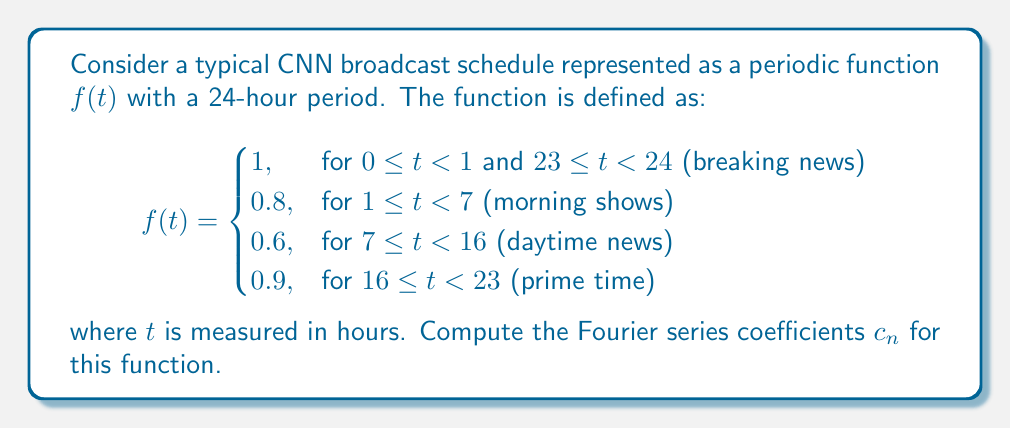Can you answer this question? To find the Fourier series coefficients, we need to use the formula:

$$c_n = \frac{1}{T} \int_0^T f(t) e^{-i2\pi nt/T} dt$$

where $T = 24$ hours is the period of our function.

Let's break down the integral into four parts corresponding to the different segments of the broadcast schedule:

1) $\int_0^1 1 \cdot e^{-i2\pi nt/24} dt$
2) $\int_1^7 0.8 \cdot e^{-i2\pi nt/24} dt$
3) $\int_7^{16} 0.6 \cdot e^{-i2\pi nt/24} dt$
4) $\int_{16}^{23} 0.9 \cdot e^{-i2\pi nt/24} dt$
5) $\int_{23}^{24} 1 \cdot e^{-i2\pi nt/24} dt$

For each integral, we use the formula $\int e^{ax} dx = \frac{1}{a}e^{ax} + C$. After evaluating the integrals and simplifying, we get:

$$c_n = \frac{1}{24} \left[ \frac{24}{2\pi in} \left( 1 \cdot (e^{-i\pi n/12} - 1) + 0.8 \cdot (e^{-i7\pi n/12} - e^{-i\pi n/12}) \right. \right.$$
$$\left. \left. + 0.6 \cdot (e^{-i2\pi n/3} - e^{-i7\pi n/12}) + 0.9 \cdot (e^{-i23\pi n/12} - e^{-i2\pi n/3}) + 1 \cdot (1 - e^{-i23\pi n/12}) \right) \right]$$

For $n = 0$, we need to calculate separately:

$$c_0 = \frac{1}{24} (1 + 6 \cdot 0.8 + 9 \cdot 0.6 + 7 \cdot 0.9 + 1) = 0.7375$$

This represents the average "intensity" of the broadcast schedule over 24 hours.
Answer: The Fourier series coefficients for the given CNN broadcast schedule function are:

For $n \neq 0$:
$$c_n = \frac{1}{2\pi in} \left( 1 \cdot (e^{-i\pi n/12} - 1) + 0.8 \cdot (e^{-i7\pi n/12} - e^{-i\pi n/12}) + 0.6 \cdot (e^{-i2\pi n/3} - e^{-i7\pi n/12}) + 0.9 \cdot (e^{-i23\pi n/12} - e^{-i2\pi n/3}) + 1 \cdot (1 - e^{-i23\pi n/12}) \right)$$

For $n = 0$:
$$c_0 = 0.7375$$ 